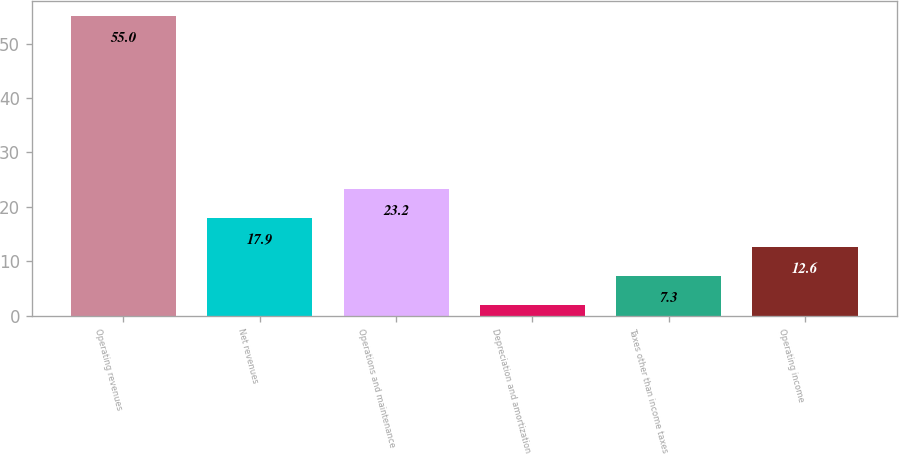<chart> <loc_0><loc_0><loc_500><loc_500><bar_chart><fcel>Operating revenues<fcel>Net revenues<fcel>Operations and maintenance<fcel>Depreciation and amortization<fcel>Taxes other than income taxes<fcel>Operating income<nl><fcel>55<fcel>17.9<fcel>23.2<fcel>2<fcel>7.3<fcel>12.6<nl></chart> 